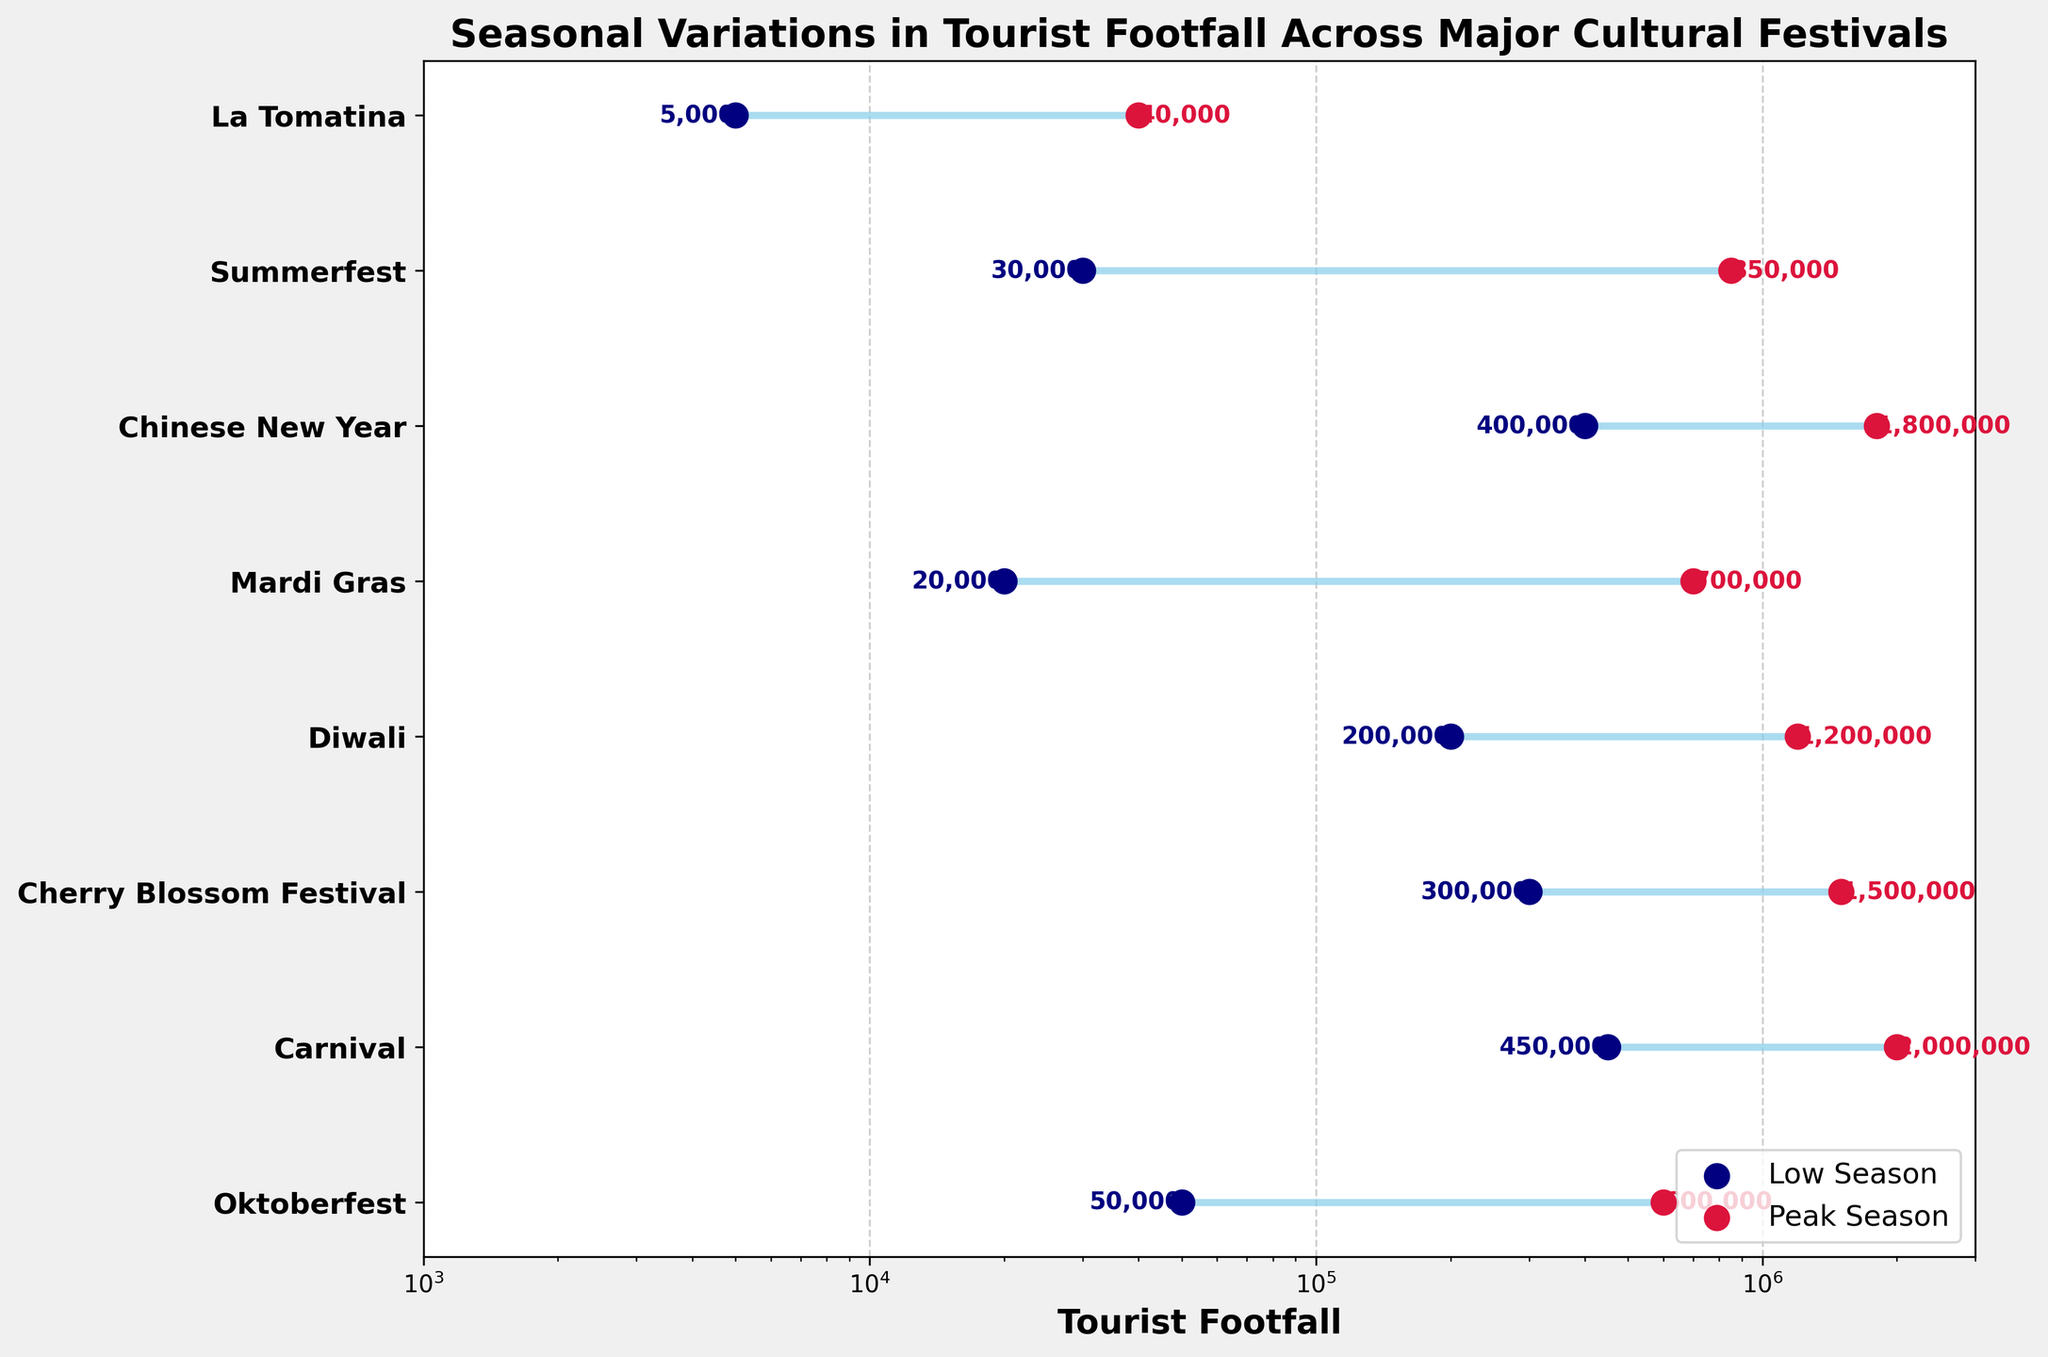What's the title of the figure? The title is displayed at the top of the figure in bold text and reads "Seasonal Variations in Tourist Footfall Across Major Cultural Festivals."
Answer: Seasonal Variations in Tourist Footfall Across Major Cultural Festivals What do the colors navy blue and crimson represent in the plot? The navy blue points represent tourist footfall during the low season, while the crimson points represent tourist footfall during the peak season. This is indicated by the legend in the lower right corner.
Answer: Low Season and Peak Season Which festival has the highest tourist footfall during peak season? The peak season values are marked by crimson dots, and the festival with the highest value is "Carnival" in Rio de Janeiro with 2,000,000 tourists.
Answer: Carnival in Rio de Janeiro How much is the tourist footfall difference between low and peak season for Oktoberfest? For Oktoberfest, the footfall for the low season is 50,000, and for the peak season, it is 600,000. The difference is calculated as 600,000 - 50,000.
Answer: 550,000 Which festival has the smallest tourist footfall difference between low and peak season? By comparing the differences visually, La Tomatina in Buñol shows the smallest difference between low (5,000) and peak (40,000) season, which is 40,000 - 5,000.
Answer: La Tomatina in Buñol What is the tourist footfall during the low season for Mardi Gras? The navy blue dot representing the low season for Mardi Gras is labeled with the value 20,000.
Answer: 20,000 Which festivals have a tourist footfall greater than 1,000,000 during peak season? The crimson dots above 1,000,000 are for Carnival in Rio de Janeiro (2,000,000), Cherry Blossom Festival in Kyoto (1,500,000), Diwali in New Delhi (1,200,000), and Chinese New Year in Beijing (1,800,000).
Answer: Carnival, Cherry Blossom Festival, Diwali, Chinese New Year What is the average tourist footfall difference between low and peak seasons for Summerfest and Cherry Blossom Festival? The differences for Summerfest (850,000 - 30,000 = 820,000) and Cherry Blossom Festival (1,500,000 - 300,000 = 1,200,000) are first calculated, then the average is (820,000 + 1,200,000) / 2.
Answer: 1,010,000 How does the tourist footfall during the low season for Chinese New Year compare to that of Carnival? The low season tourist footfall for Chinese New Year is 400,000 and for Carnival, it's 450,000. 400,000 is less than 450,000.
Answer: Chinese New Year < Carnival What is the median tourist footfall during peak season for the listed festivals? The peak seasons arranged in ascending order are 40,000, 700,000, 850,000, 1,200,000, 1,500,000, 1,800,000, 2,000,000. Since there are 8 festivals, the median is the average of the 4th and 5th values: (1,200,000 + 1,500,000) / 2.
Answer: 1,350,000 